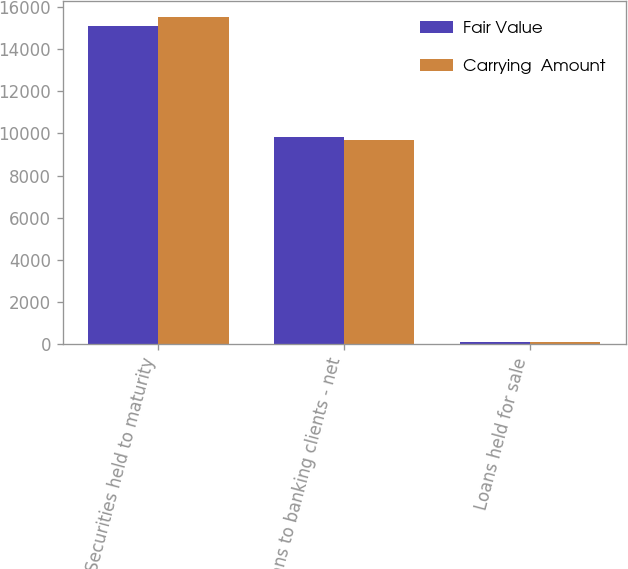Convert chart. <chart><loc_0><loc_0><loc_500><loc_500><stacked_bar_chart><ecel><fcel>Securities held to maturity<fcel>Loans to banking clients - net<fcel>Loans held for sale<nl><fcel>Fair Value<fcel>15108<fcel>9812<fcel>70<nl><fcel>Carrying  Amount<fcel>15539<fcel>9671<fcel>73<nl></chart> 